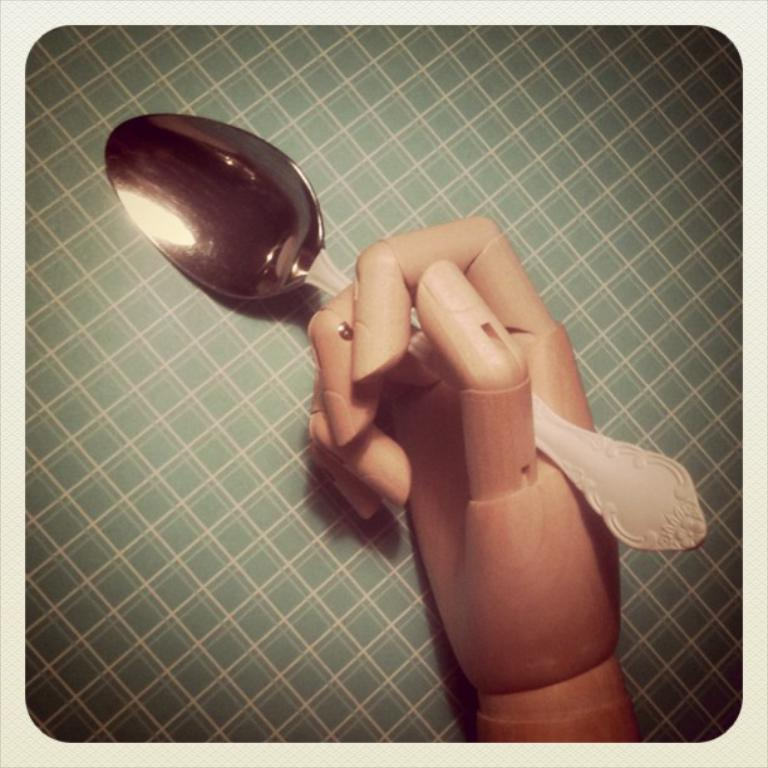What is the toy hand holding in the image? The toy hand is holding a spoon in the image. What type of surface is visible in the image? There is a check surface in the image. What color is the border of the image? The borders of the image are white. What type of lunch is the toy hand eating in the image? There is no lunch present in the image; it only features a toy hand holding a spoon. 